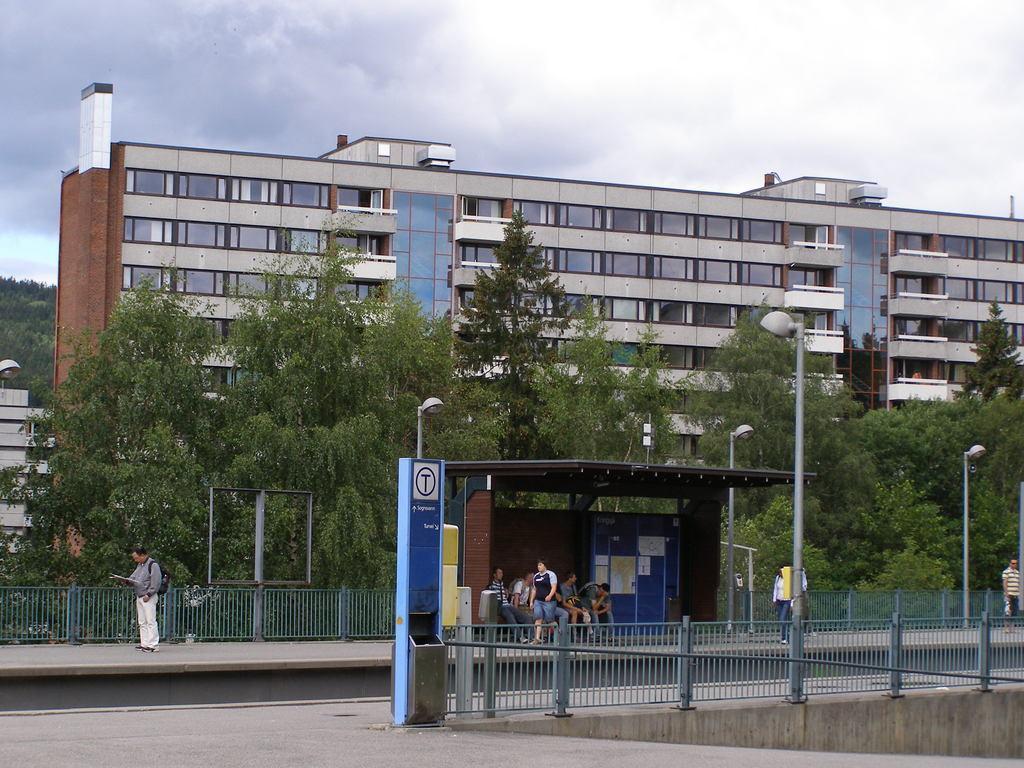In one or two sentences, can you explain what this image depicts? In this image, we can see few people. Here few people are sitting. Here a person is walking on the walkway. At the bottom, we can see wall, grills, poles, path, posters, street lights and trees. Background we can see buildings, trees, hills, walls, glass windows and cloudy sky. 